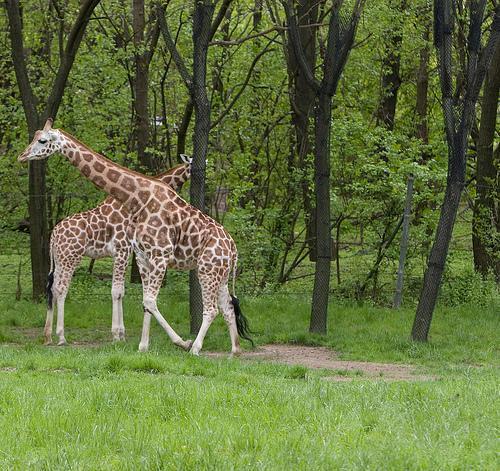How many animals are there?
Give a very brief answer. 2. How many giraffes in this photo?
Give a very brief answer. 2. How many giraffes?
Give a very brief answer. 2. How many animals are in the picture?
Give a very brief answer. 2. How many giraffes are there?
Give a very brief answer. 2. 